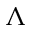Convert formula to latex. <formula><loc_0><loc_0><loc_500><loc_500>\Lambda</formula> 